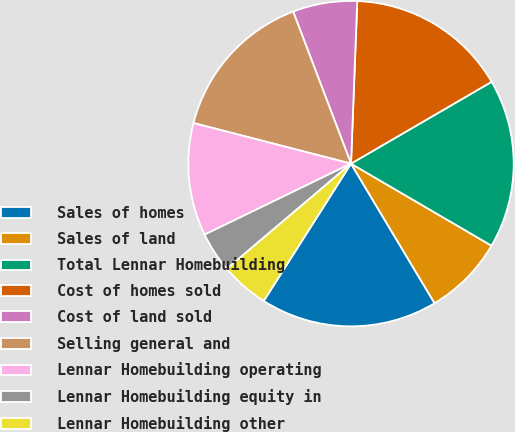Convert chart. <chart><loc_0><loc_0><loc_500><loc_500><pie_chart><fcel>Sales of homes<fcel>Sales of land<fcel>Total Lennar Homebuilding<fcel>Cost of homes sold<fcel>Cost of land sold<fcel>Selling general and<fcel>Lennar Homebuilding operating<fcel>Lennar Homebuilding equity in<fcel>Lennar Homebuilding other<nl><fcel>17.6%<fcel>8.0%<fcel>16.8%<fcel>16.0%<fcel>6.4%<fcel>15.2%<fcel>11.2%<fcel>4.0%<fcel>4.8%<nl></chart> 